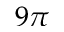Convert formula to latex. <formula><loc_0><loc_0><loc_500><loc_500>9 \pi</formula> 